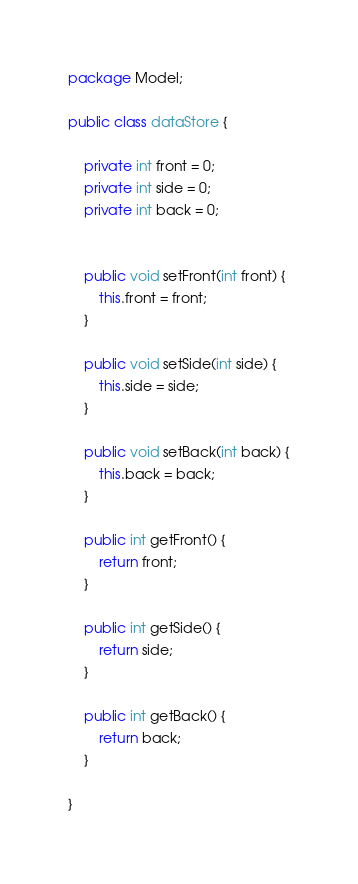<code> <loc_0><loc_0><loc_500><loc_500><_Java_>package Model;

public class dataStore {

    private int front = 0;
    private int side = 0;
    private int back = 0;


    public void setFront(int front) {
        this.front = front;
    }

    public void setSide(int side) {
        this.side = side;
    }

    public void setBack(int back) {
        this.back = back;
    }

    public int getFront() {
        return front;
    }

    public int getSide() {
        return side;
    }

    public int getBack() {
        return back;
    }

}
</code> 